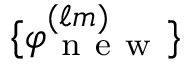<formula> <loc_0><loc_0><loc_500><loc_500>\{ \varphi _ { n e w } ^ { ( \ell m ) } \}</formula> 